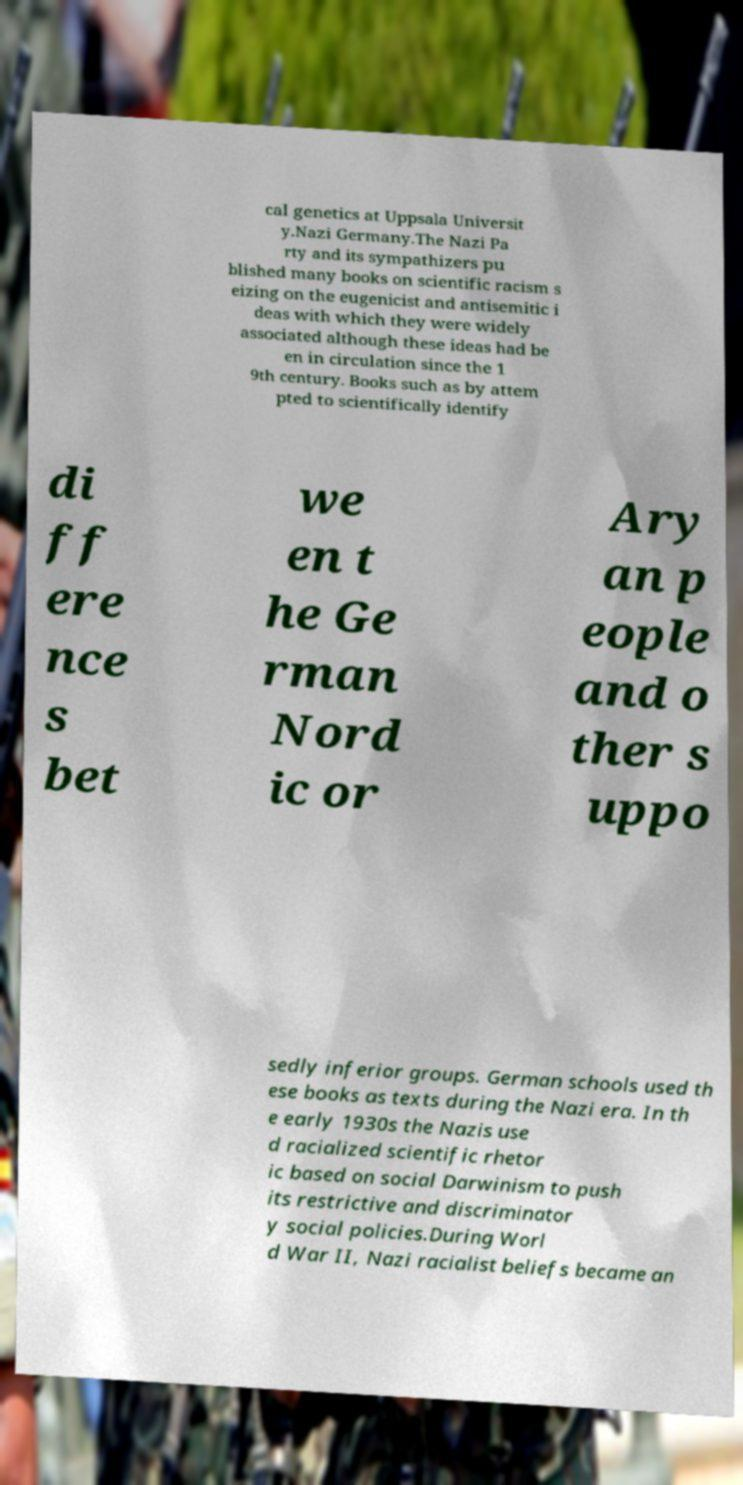Please read and relay the text visible in this image. What does it say? cal genetics at Uppsala Universit y.Nazi Germany.The Nazi Pa rty and its sympathizers pu blished many books on scientific racism s eizing on the eugenicist and antisemitic i deas with which they were widely associated although these ideas had be en in circulation since the 1 9th century. Books such as by attem pted to scientifically identify di ff ere nce s bet we en t he Ge rman Nord ic or Ary an p eople and o ther s uppo sedly inferior groups. German schools used th ese books as texts during the Nazi era. In th e early 1930s the Nazis use d racialized scientific rhetor ic based on social Darwinism to push its restrictive and discriminator y social policies.During Worl d War II, Nazi racialist beliefs became an 